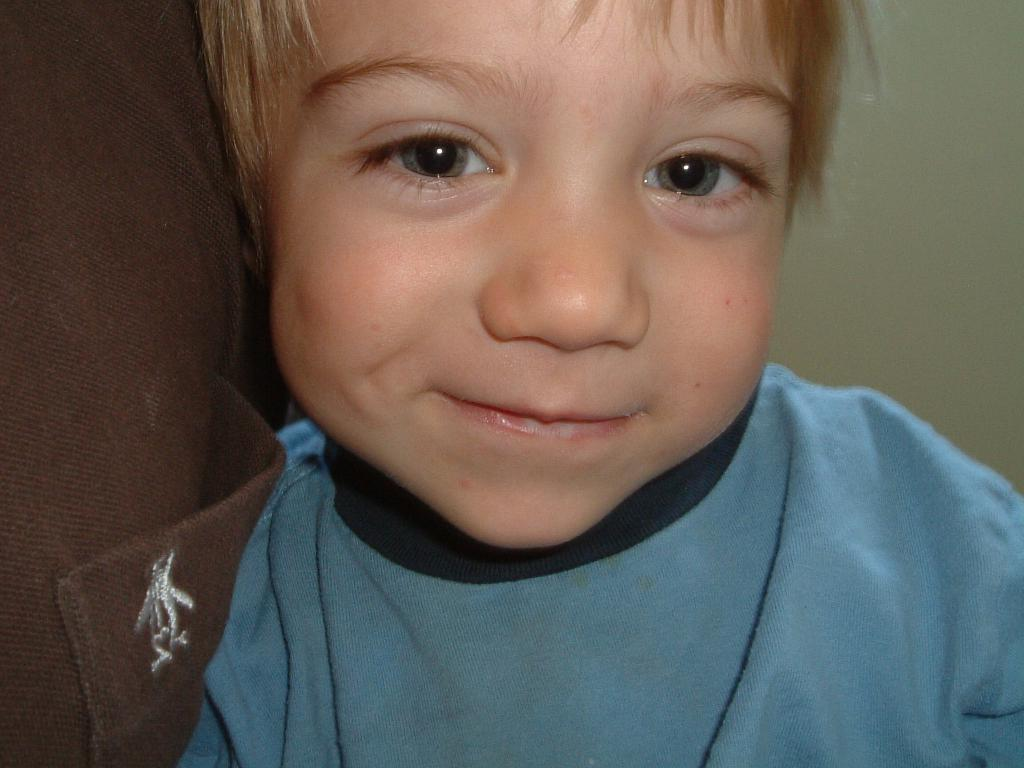What is the main subject of the picture? The main subject of the picture is a boy. What is the boy wearing in the picture? The boy is wearing a blue t-shirt. What expression does the boy have in the picture? The boy is smiling. How many rings does the boy have on his finger in the picture? There is no mention of rings in the provided facts, so we cannot determine if the boy has any rings on his finger in the image. 